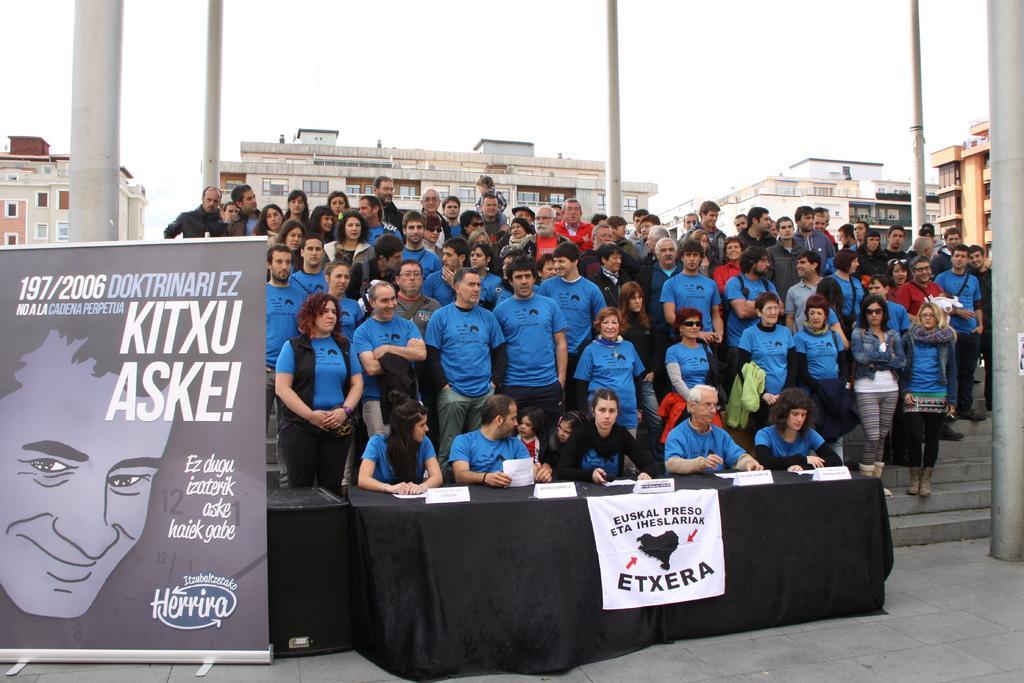Describe this image in one or two sentences. In this image we can see a few people, among them some people are standing on the stairs and some people are sitting on the chairs, in front of them, we can see a table covered with black color cloth, on the table, we can see some name boards and papers, we can see a poster with some text and image, in the background we can see a few buildings, poles and the sky. 